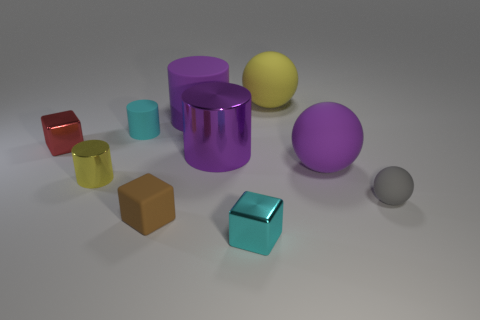Is there a block made of the same material as the large purple ball?
Offer a very short reply. Yes. What color is the other big object that is the same shape as the big yellow thing?
Keep it short and to the point. Purple. Are there fewer small cyan objects in front of the tiny brown object than matte cylinders to the right of the tiny sphere?
Your response must be concise. No. How many other things are the same shape as the small red metallic object?
Your response must be concise. 2. Are there fewer small yellow objects that are in front of the tiny brown rubber block than large red metal objects?
Provide a short and direct response. No. There is a big purple thing that is on the right side of the cyan metallic cube; what is its material?
Ensure brevity in your answer.  Rubber. What number of other objects are the same size as the cyan metallic thing?
Your answer should be compact. 5. Is the number of tiny blue spheres less than the number of small cyan blocks?
Make the answer very short. Yes. What is the shape of the large purple metal thing?
Your answer should be very brief. Cylinder. Do the small metal cube behind the brown object and the large matte cylinder have the same color?
Your answer should be compact. No. 